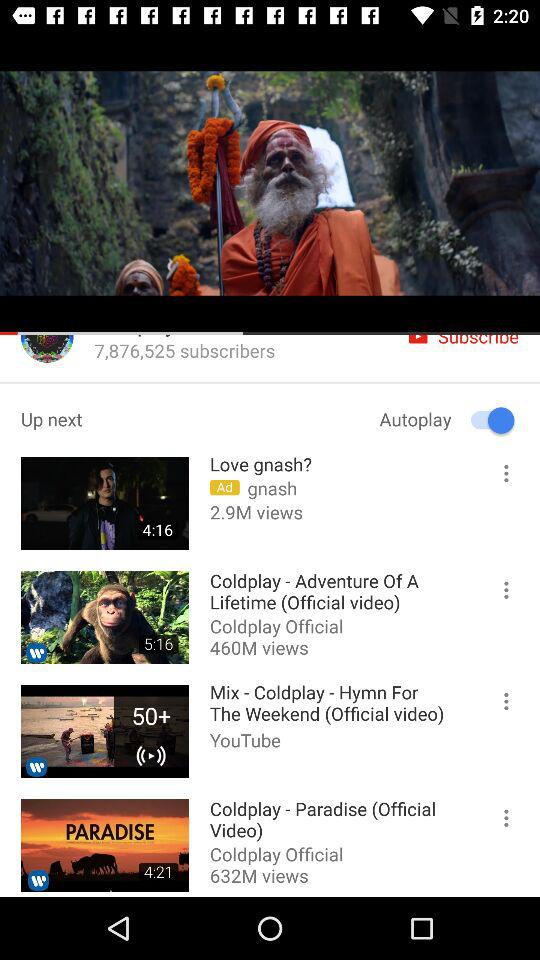What is the total number of views on "Coldplay - Paradise"? There are total 632 millions views on "Coldplay - Paradise". 